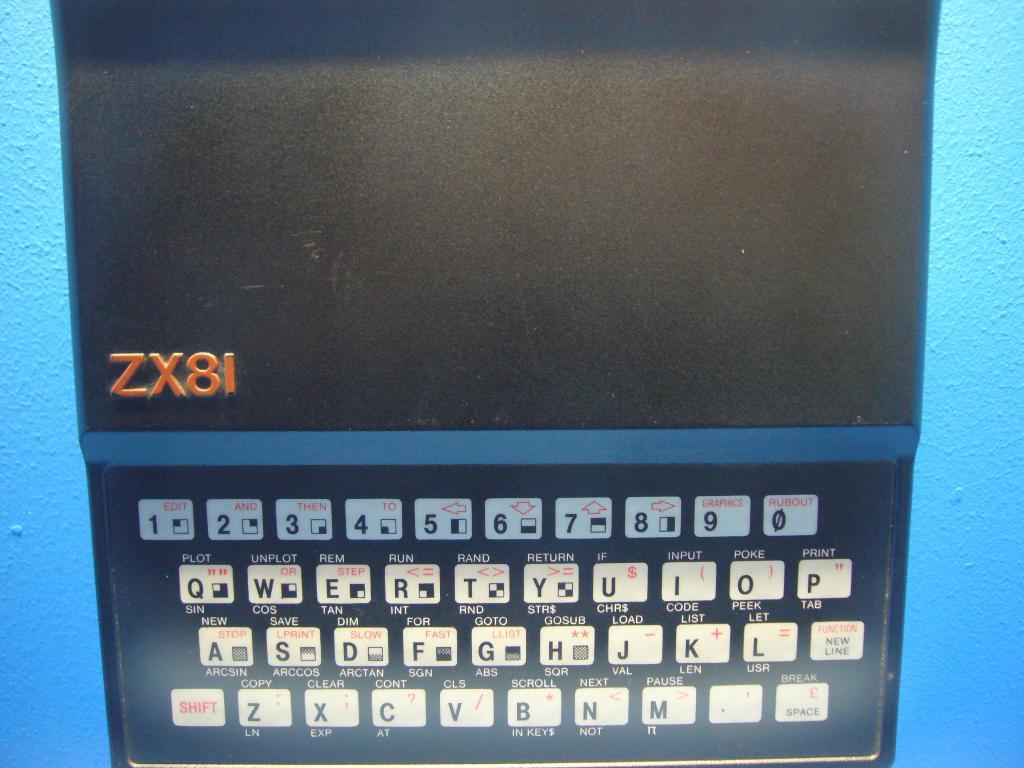What number is the last key on the top row?
Offer a very short reply. 0. What it is keyboard?
Offer a very short reply. Yes. 